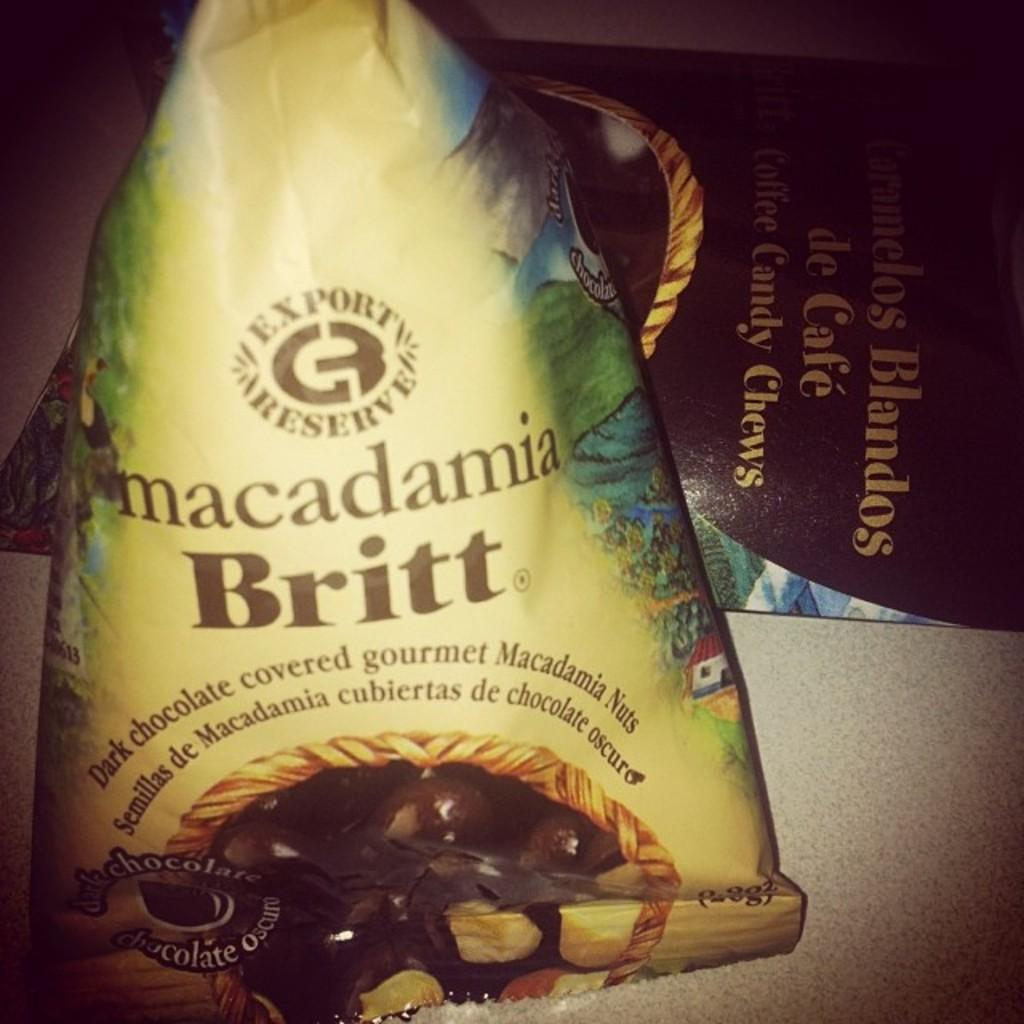<image>
Share a concise interpretation of the image provided. A bag of dark chocolate covered gourmet Britt macadamia nuts. 